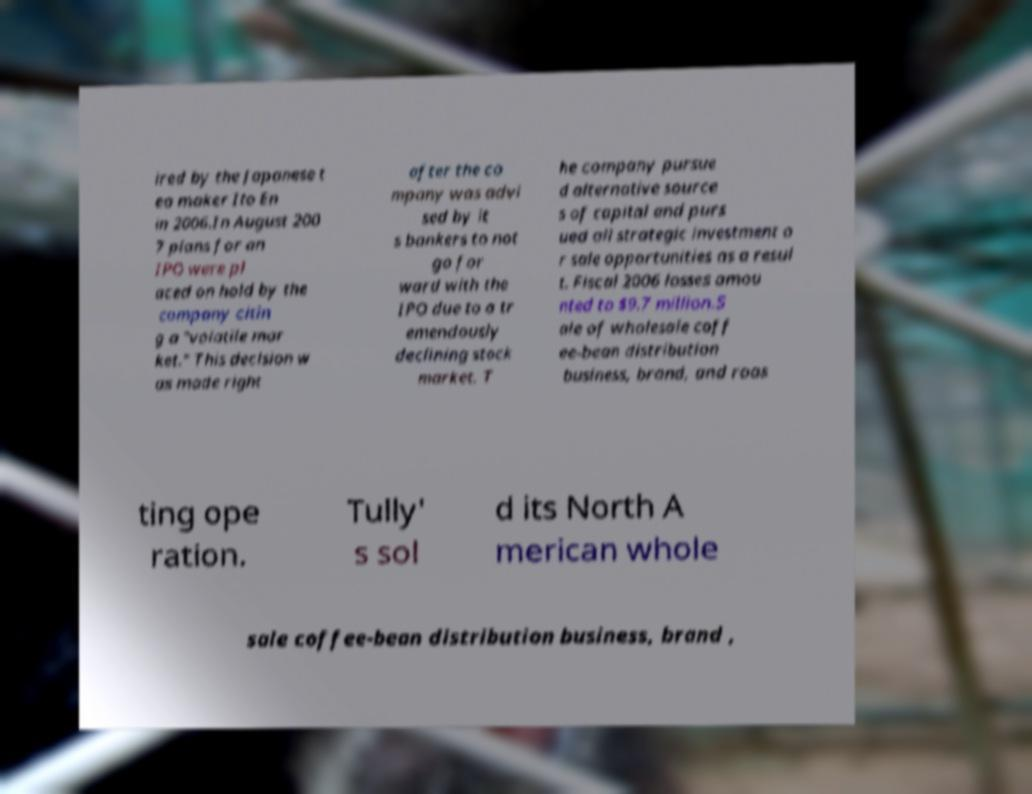Could you assist in decoding the text presented in this image and type it out clearly? ired by the Japanese t ea maker Ito En in 2006.In August 200 7 plans for an IPO were pl aced on hold by the company citin g a "volatile mar ket." This decision w as made right after the co mpany was advi sed by it s bankers to not go for ward with the IPO due to a tr emendously declining stock market. T he company pursue d alternative source s of capital and purs ued all strategic investment o r sale opportunities as a resul t. Fiscal 2006 losses amou nted to $9.7 million.S ale of wholesale coff ee-bean distribution business, brand, and roas ting ope ration. Tully' s sol d its North A merican whole sale coffee-bean distribution business, brand , 